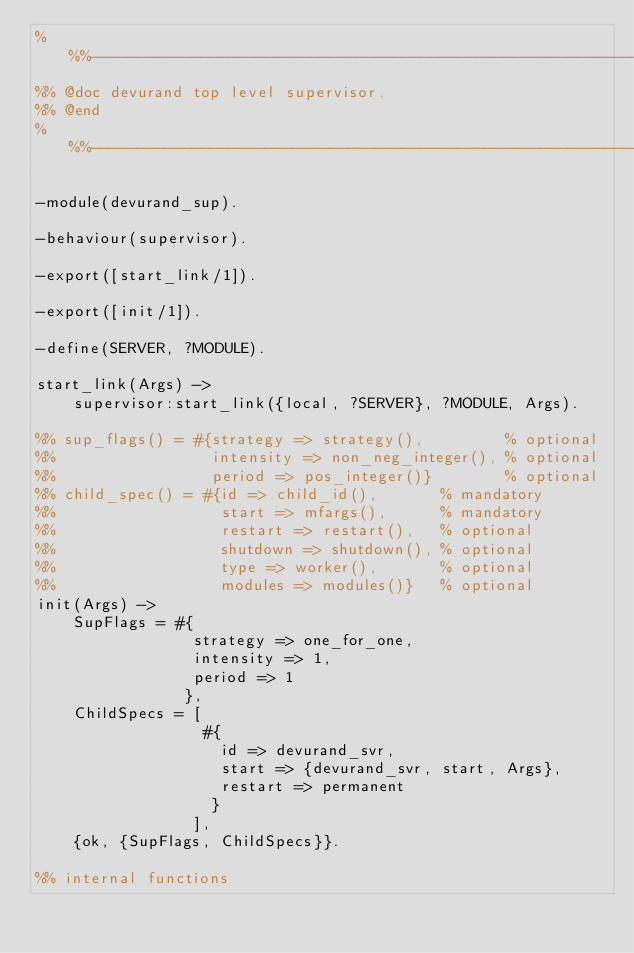<code> <loc_0><loc_0><loc_500><loc_500><_Erlang_>%%%-------------------------------------------------------------------
%% @doc devurand top level supervisor.
%% @end
%%%-------------------------------------------------------------------

-module(devurand_sup).

-behaviour(supervisor).

-export([start_link/1]).

-export([init/1]).

-define(SERVER, ?MODULE).

start_link(Args) ->
    supervisor:start_link({local, ?SERVER}, ?MODULE, Args).

%% sup_flags() = #{strategy => strategy(),         % optional
%%                 intensity => non_neg_integer(), % optional
%%                 period => pos_integer()}        % optional
%% child_spec() = #{id => child_id(),       % mandatory
%%                  start => mfargs(),      % mandatory
%%                  restart => restart(),   % optional
%%                  shutdown => shutdown(), % optional
%%                  type => worker(),       % optional
%%                  modules => modules()}   % optional
init(Args) ->
    SupFlags = #{
                 strategy => one_for_one,
                 intensity => 1,
                 period => 1
                },
    ChildSpecs = [
                  #{
                    id => devurand_svr,
                    start => {devurand_svr, start, Args},
                    restart => permanent
                   }
                 ],
    {ok, {SupFlags, ChildSpecs}}.

%% internal functions
</code> 